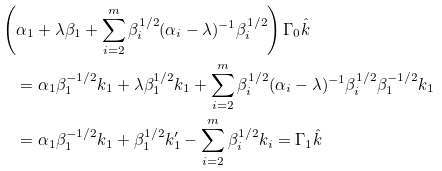<formula> <loc_0><loc_0><loc_500><loc_500>& \left ( \alpha _ { 1 } + \lambda \beta _ { 1 } + \sum _ { i = 2 } ^ { m } \beta _ { i } ^ { 1 / 2 } ( \alpha _ { i } - \lambda ) ^ { - 1 } \beta _ { i } ^ { 1 / 2 } \right ) \Gamma _ { 0 } \hat { k } \\ & \quad = \alpha _ { 1 } \beta _ { 1 } ^ { - 1 / 2 } k _ { 1 } + \lambda \beta _ { 1 } ^ { 1 / 2 } k _ { 1 } + \sum _ { i = 2 } ^ { m } \beta _ { i } ^ { 1 / 2 } ( \alpha _ { i } - \lambda ) ^ { - 1 } \beta _ { i } ^ { 1 / 2 } \beta _ { 1 } ^ { - 1 / 2 } k _ { 1 } \\ & \quad = \alpha _ { 1 } \beta _ { 1 } ^ { - 1 / 2 } k _ { 1 } + \beta _ { 1 } ^ { 1 / 2 } k _ { 1 } ^ { \prime } - \sum _ { i = 2 } ^ { m } \beta _ { i } ^ { 1 / 2 } k _ { i } = \Gamma _ { 1 } \hat { k }</formula> 